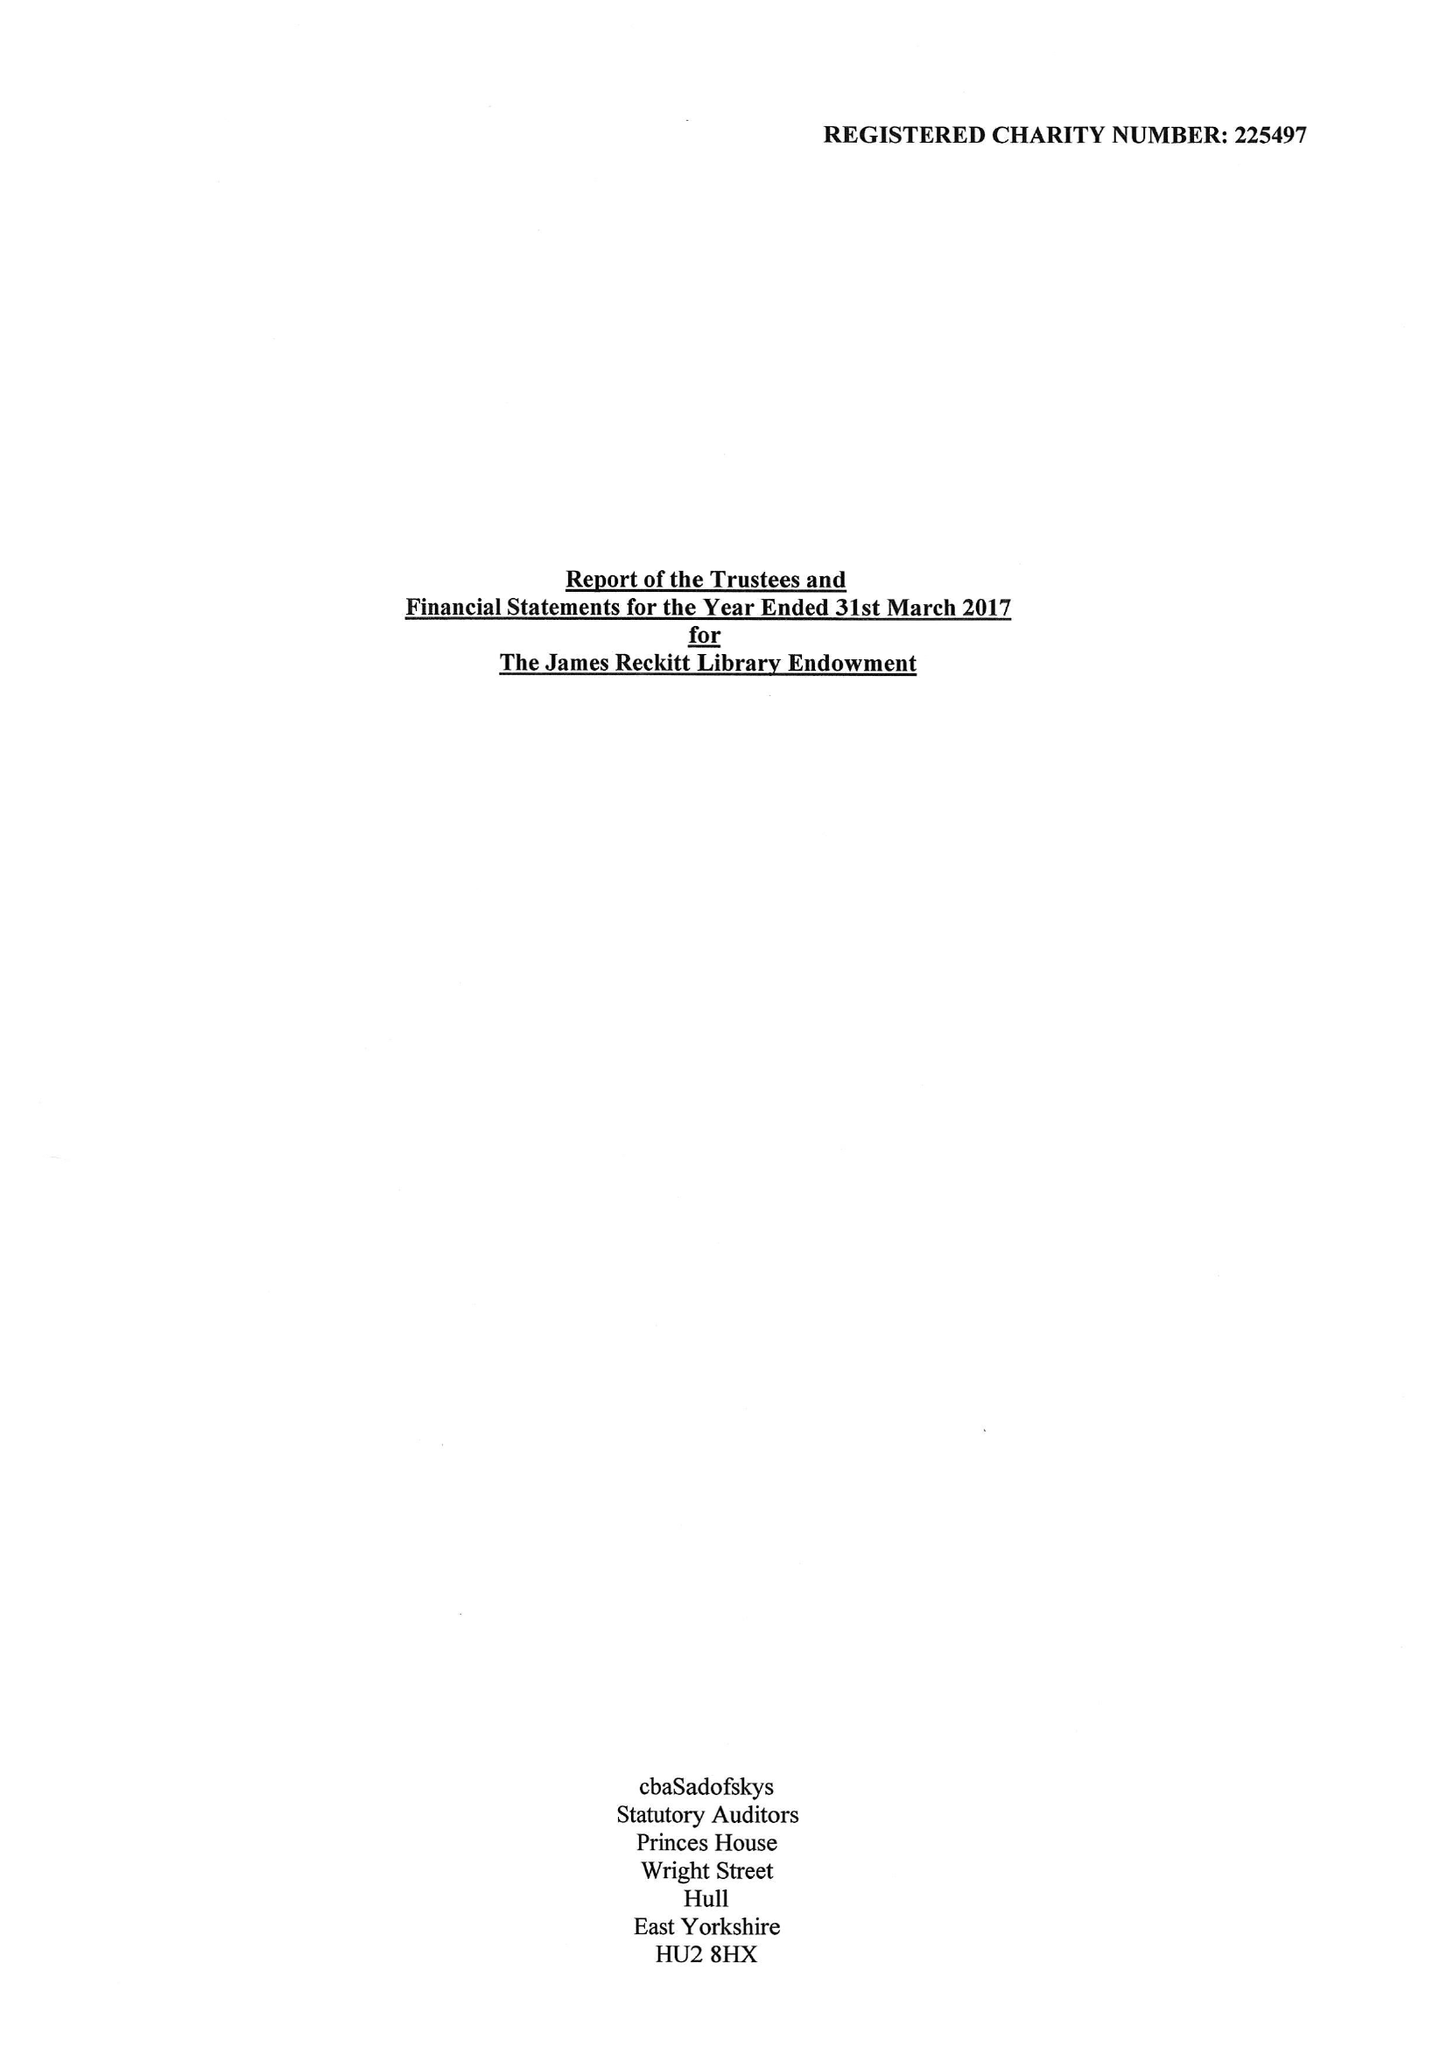What is the value for the charity_name?
Answer the question using a single word or phrase. The James Reckitt Library Endowment 